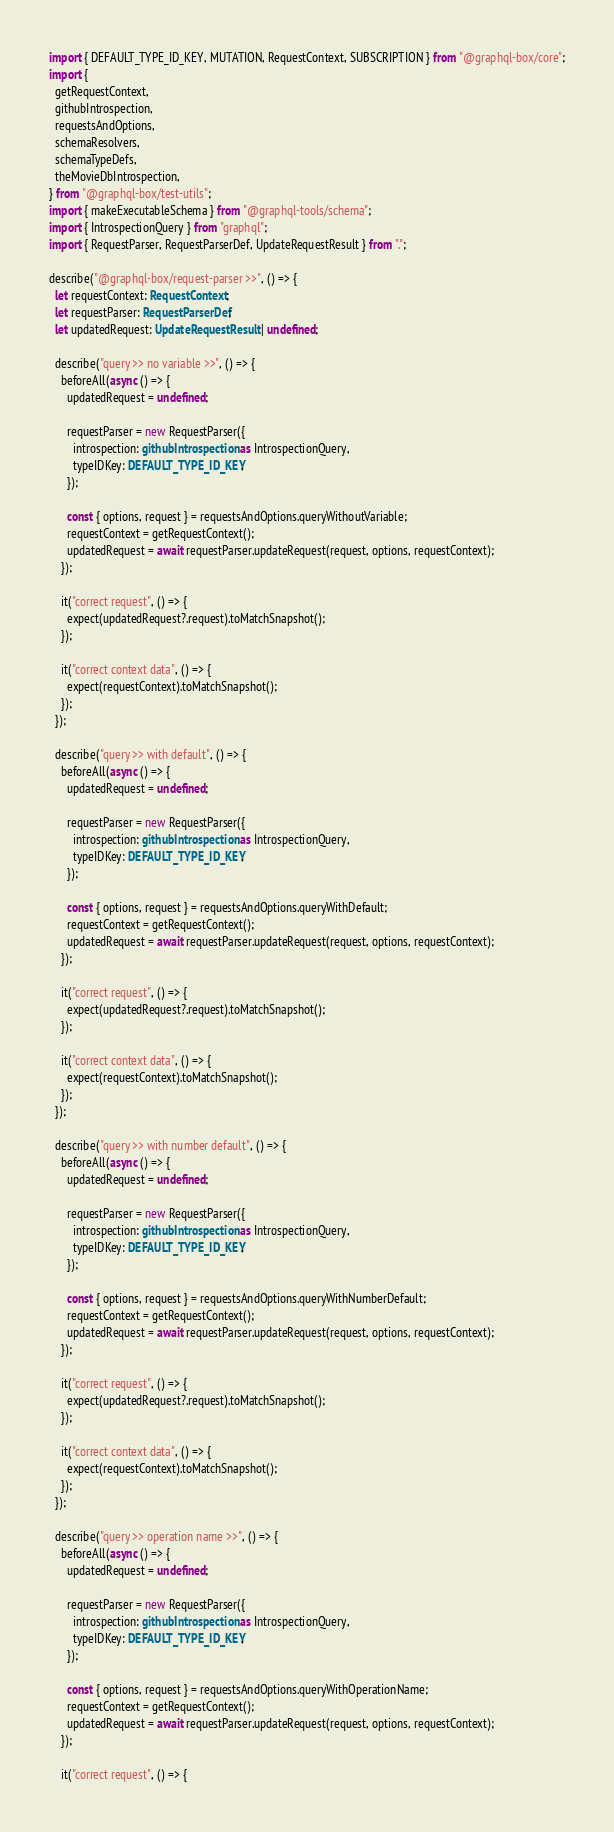Convert code to text. <code><loc_0><loc_0><loc_500><loc_500><_TypeScript_>import { DEFAULT_TYPE_ID_KEY, MUTATION, RequestContext, SUBSCRIPTION } from "@graphql-box/core";
import {
  getRequestContext,
  githubIntrospection,
  requestsAndOptions,
  schemaResolvers,
  schemaTypeDefs,
  theMovieDbIntrospection,
} from "@graphql-box/test-utils";
import { makeExecutableSchema } from "@graphql-tools/schema";
import { IntrospectionQuery } from "graphql";
import { RequestParser, RequestParserDef, UpdateRequestResult } from ".";

describe("@graphql-box/request-parser >>", () => {
  let requestContext: RequestContext;
  let requestParser: RequestParserDef;
  let updatedRequest: UpdateRequestResult | undefined;

  describe("query >> no variable >>", () => {
    beforeAll(async () => {
      updatedRequest = undefined;

      requestParser = new RequestParser({
        introspection: githubIntrospection as IntrospectionQuery,
        typeIDKey: DEFAULT_TYPE_ID_KEY,
      });

      const { options, request } = requestsAndOptions.queryWithoutVariable;
      requestContext = getRequestContext();
      updatedRequest = await requestParser.updateRequest(request, options, requestContext);
    });

    it("correct request", () => {
      expect(updatedRequest?.request).toMatchSnapshot();
    });

    it("correct context data", () => {
      expect(requestContext).toMatchSnapshot();
    });
  });

  describe("query >> with default", () => {
    beforeAll(async () => {
      updatedRequest = undefined;

      requestParser = new RequestParser({
        introspection: githubIntrospection as IntrospectionQuery,
        typeIDKey: DEFAULT_TYPE_ID_KEY,
      });

      const { options, request } = requestsAndOptions.queryWithDefault;
      requestContext = getRequestContext();
      updatedRequest = await requestParser.updateRequest(request, options, requestContext);
    });

    it("correct request", () => {
      expect(updatedRequest?.request).toMatchSnapshot();
    });

    it("correct context data", () => {
      expect(requestContext).toMatchSnapshot();
    });
  });

  describe("query >> with number default", () => {
    beforeAll(async () => {
      updatedRequest = undefined;

      requestParser = new RequestParser({
        introspection: githubIntrospection as IntrospectionQuery,
        typeIDKey: DEFAULT_TYPE_ID_KEY,
      });

      const { options, request } = requestsAndOptions.queryWithNumberDefault;
      requestContext = getRequestContext();
      updatedRequest = await requestParser.updateRequest(request, options, requestContext);
    });

    it("correct request", () => {
      expect(updatedRequest?.request).toMatchSnapshot();
    });

    it("correct context data", () => {
      expect(requestContext).toMatchSnapshot();
    });
  });

  describe("query >> operation name >>", () => {
    beforeAll(async () => {
      updatedRequest = undefined;

      requestParser = new RequestParser({
        introspection: githubIntrospection as IntrospectionQuery,
        typeIDKey: DEFAULT_TYPE_ID_KEY,
      });

      const { options, request } = requestsAndOptions.queryWithOperationName;
      requestContext = getRequestContext();
      updatedRequest = await requestParser.updateRequest(request, options, requestContext);
    });

    it("correct request", () => {</code> 